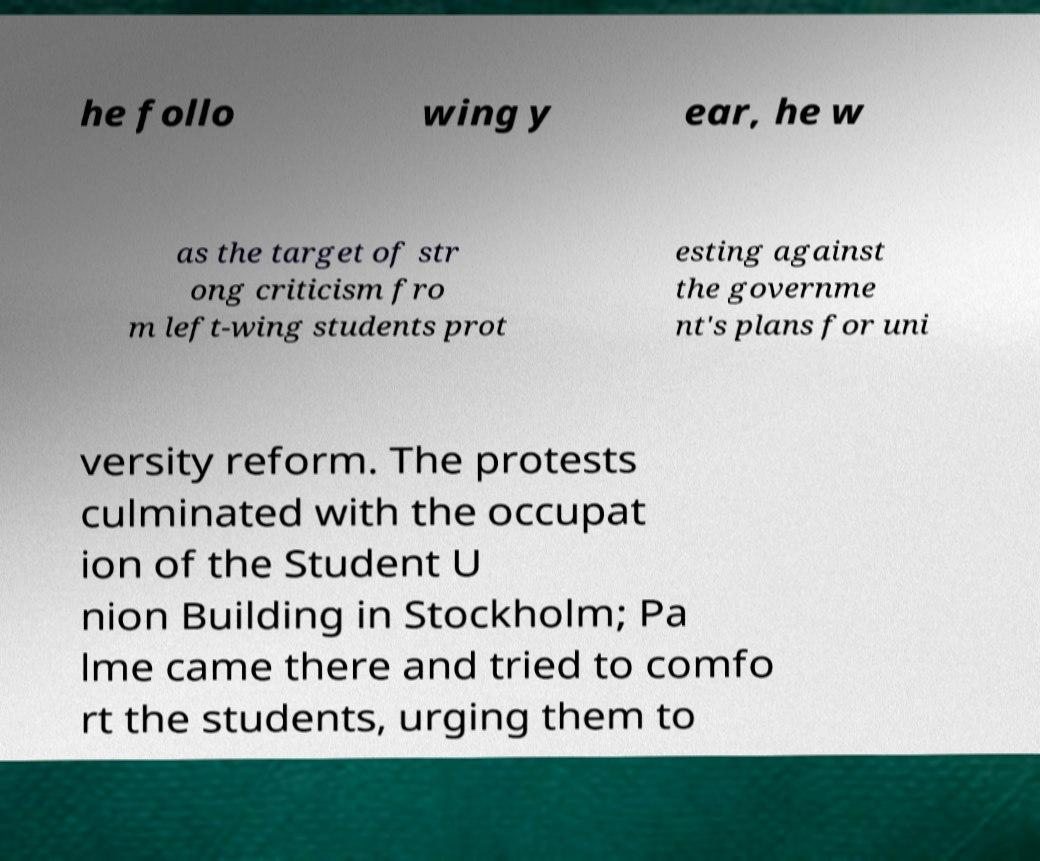Can you accurately transcribe the text from the provided image for me? he follo wing y ear, he w as the target of str ong criticism fro m left-wing students prot esting against the governme nt's plans for uni versity reform. The protests culminated with the occupat ion of the Student U nion Building in Stockholm; Pa lme came there and tried to comfo rt the students, urging them to 